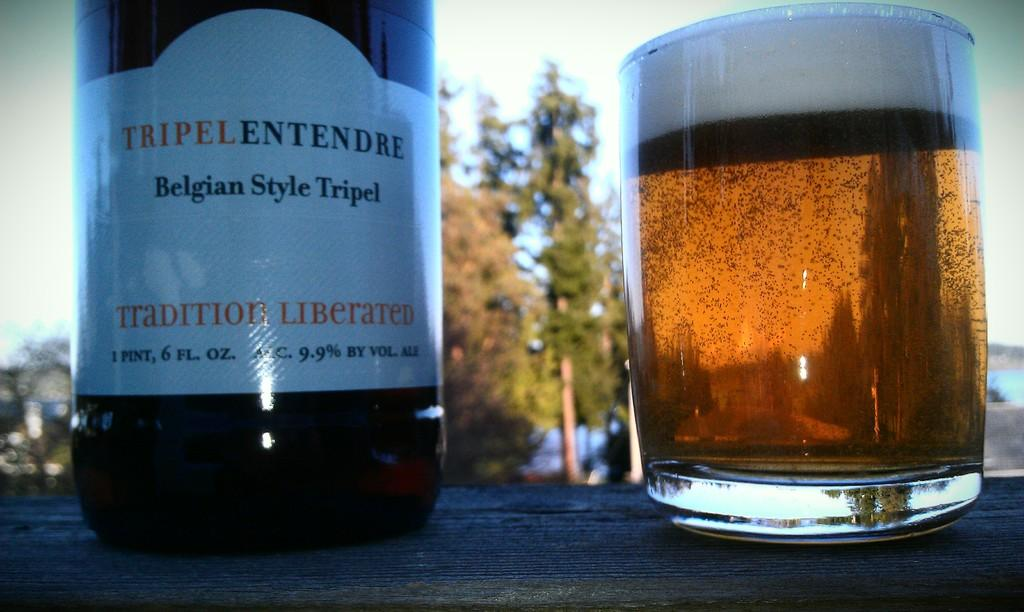<image>
Give a short and clear explanation of the subsequent image. A bottle of Belgian Style Tripel sits next to a glass of amber liquid. 